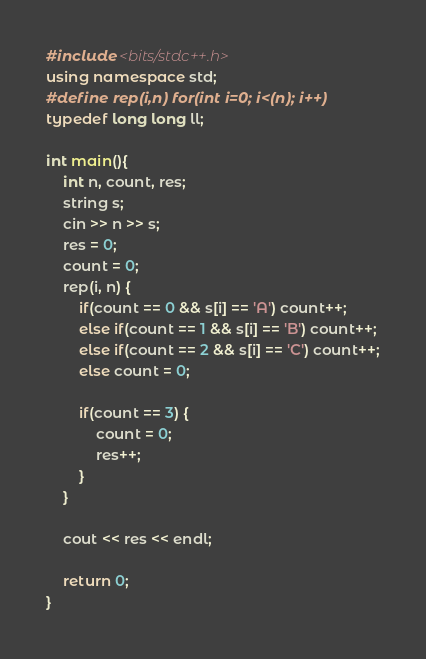Convert code to text. <code><loc_0><loc_0><loc_500><loc_500><_C++_>#include <bits/stdc++.h>
using namespace std;
#define rep(i,n) for(int i=0; i<(n); i++)
typedef long long ll;

int main(){
    int n, count, res;
    string s;
    cin >> n >> s;
    res = 0;
    count = 0;
    rep(i, n) {
        if(count == 0 && s[i] == 'A') count++;
        else if(count == 1 && s[i] == 'B') count++;
        else if(count == 2 && s[i] == 'C') count++;
        else count = 0;

        if(count == 3) {
            count = 0;
            res++;
        }
    }

    cout << res << endl;

    return 0;
}</code> 